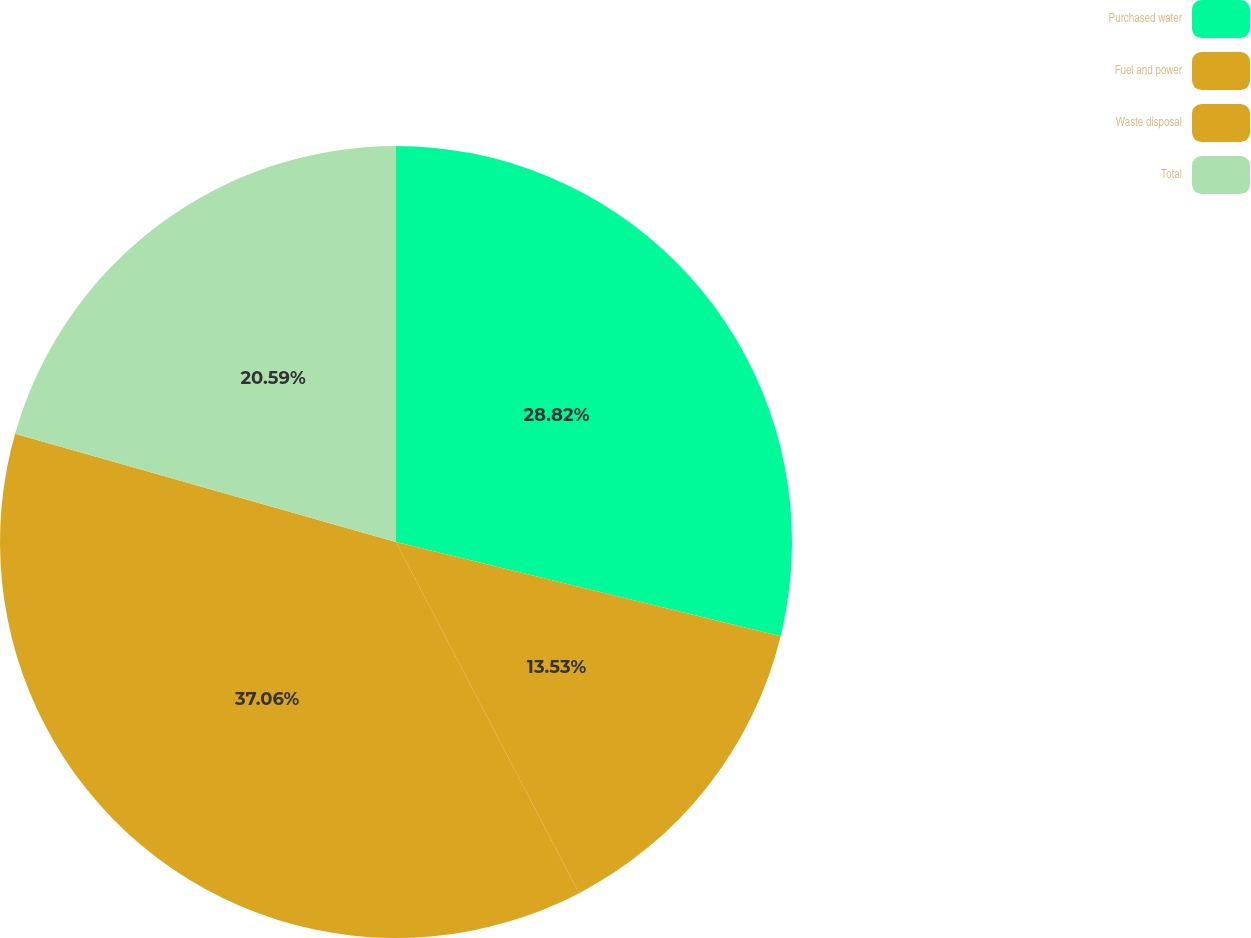Convert chart to OTSL. <chart><loc_0><loc_0><loc_500><loc_500><pie_chart><fcel>Purchased water<fcel>Fuel and power<fcel>Waste disposal<fcel>Total<nl><fcel>28.82%<fcel>13.53%<fcel>37.06%<fcel>20.59%<nl></chart> 